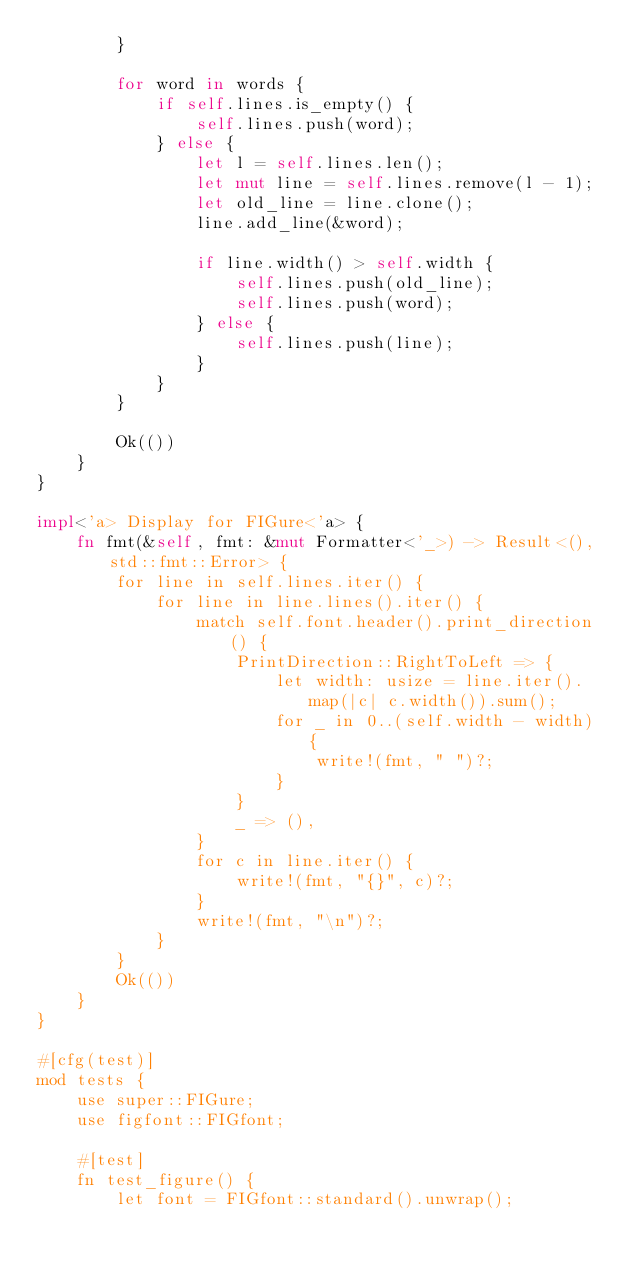<code> <loc_0><loc_0><loc_500><loc_500><_Rust_>        }

        for word in words {
            if self.lines.is_empty() {
                self.lines.push(word);
            } else {
                let l = self.lines.len();
                let mut line = self.lines.remove(l - 1);
                let old_line = line.clone();
                line.add_line(&word);

                if line.width() > self.width {
                    self.lines.push(old_line);
                    self.lines.push(word);
                } else {
                    self.lines.push(line);
                }
            }
        }

        Ok(())
    }
}

impl<'a> Display for FIGure<'a> {
    fn fmt(&self, fmt: &mut Formatter<'_>) -> Result<(), std::fmt::Error> {
        for line in self.lines.iter() {
            for line in line.lines().iter() {
                match self.font.header().print_direction() {
                    PrintDirection::RightToLeft => {
                        let width: usize = line.iter().map(|c| c.width()).sum();
                        for _ in 0..(self.width - width) {
                            write!(fmt, " ")?;
                        }
                    }
                    _ => (),
                }
                for c in line.iter() {
                    write!(fmt, "{}", c)?;
                }
                write!(fmt, "\n")?;
            }
        }
        Ok(())
    }
}

#[cfg(test)]
mod tests {
    use super::FIGure;
    use figfont::FIGfont;

    #[test]
    fn test_figure() {
        let font = FIGfont::standard().unwrap();</code> 